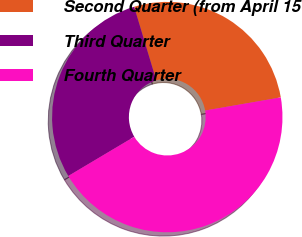Convert chart to OTSL. <chart><loc_0><loc_0><loc_500><loc_500><pie_chart><fcel>Second Quarter (from April 15<fcel>Third Quarter<fcel>Fourth Quarter<nl><fcel>26.91%<fcel>28.9%<fcel>44.19%<nl></chart> 